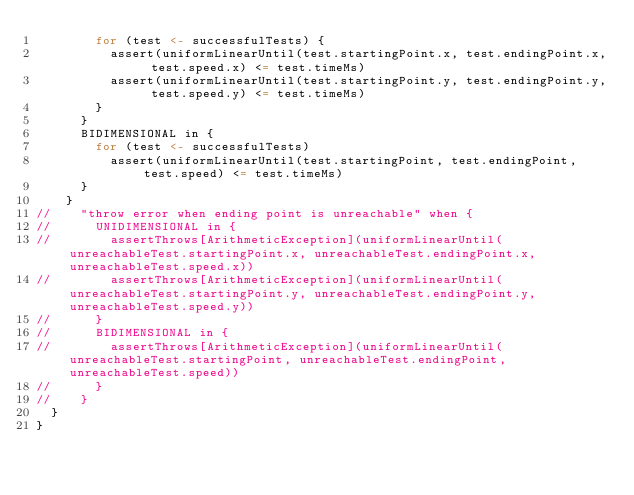Convert code to text. <code><loc_0><loc_0><loc_500><loc_500><_Scala_>        for (test <- successfulTests) {
          assert(uniformLinearUntil(test.startingPoint.x, test.endingPoint.x, test.speed.x) <= test.timeMs)
          assert(uniformLinearUntil(test.startingPoint.y, test.endingPoint.y, test.speed.y) <= test.timeMs)
        }
      }
      BIDIMENSIONAL in {
        for (test <- successfulTests)
          assert(uniformLinearUntil(test.startingPoint, test.endingPoint, test.speed) <= test.timeMs)
      }
    }
//    "throw error when ending point is unreachable" when {
//      UNIDIMENSIONAL in {
//        assertThrows[ArithmeticException](uniformLinearUntil(unreachableTest.startingPoint.x, unreachableTest.endingPoint.x, unreachableTest.speed.x))
//        assertThrows[ArithmeticException](uniformLinearUntil(unreachableTest.startingPoint.y, unreachableTest.endingPoint.y, unreachableTest.speed.y))
//      }
//      BIDIMENSIONAL in {
//        assertThrows[ArithmeticException](uniformLinearUntil(unreachableTest.startingPoint, unreachableTest.endingPoint, unreachableTest.speed))
//      }
//    }
  }
}
</code> 